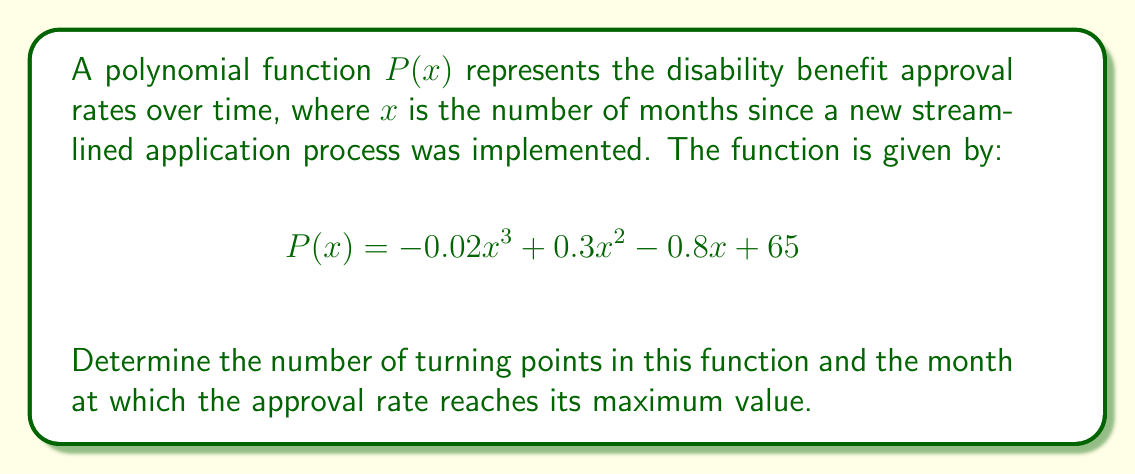Teach me how to tackle this problem. 1) To find the turning points, we need to find the roots of the derivative of $P(x)$.

2) The derivative of $P(x)$ is:
   $$P'(x) = -0.06x^2 + 0.6x - 0.8$$

3) The turning points occur where $P'(x) = 0$. So we need to solve:
   $$-0.06x^2 + 0.6x - 0.8 = 0$$

4) This is a quadratic equation. We can solve it using the quadratic formula:
   $$x = \frac{-b \pm \sqrt{b^2 - 4ac}}{2a}$$
   where $a = -0.06$, $b = 0.6$, and $c = -0.8$

5) Plugging in these values:
   $$x = \frac{-0.6 \pm \sqrt{0.6^2 - 4(-0.06)(-0.8)}}{2(-0.06)}$$
   $$= \frac{-0.6 \pm \sqrt{0.36 - 0.192}}{-0.12}$$
   $$= \frac{-0.6 \pm \sqrt{0.168}}{-0.12}$$
   $$= \frac{-0.6 \pm 0.41}{-0.12}$$

6) This gives us two solutions:
   $$x_1 = \frac{-0.6 + 0.41}{-0.12} \approx 1.58$$
   $$x_2 = \frac{-0.6 - 0.41}{-0.12} \approx 8.42$$

7) These are the two turning points of the function.

8) To determine which one is the maximum, we can check the second derivative:
   $$P''(x) = -0.12x + 0.6$$

9) At $x = 1.58$, $P''(1.58) = -0.12(1.58) + 0.6 = 0.4104 > 0$, so this is a minimum.
   At $x = 8.42$, $P''(8.42) = -0.12(8.42) + 0.6 = -0.4104 < 0$, so this is a maximum.

10) Therefore, the approval rate reaches its maximum value at approximately 8.42 months.
Answer: 2 turning points; maximum at 8.42 months 